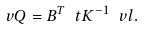<formula> <loc_0><loc_0><loc_500><loc_500>\ v Q = B ^ { T } \ t K ^ { - 1 } \ v l .</formula> 